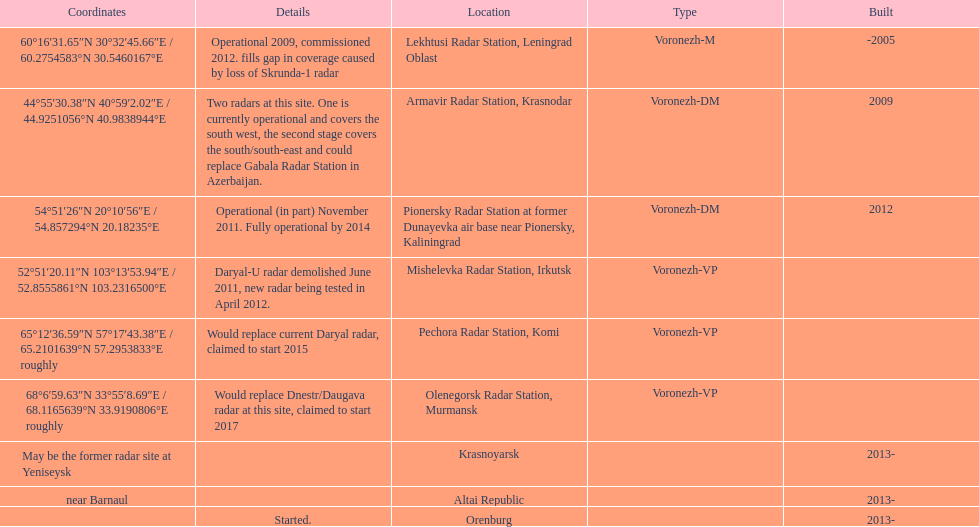How long did it take the pionersky radar station to go from partially operational to fully operational? 3 years. 